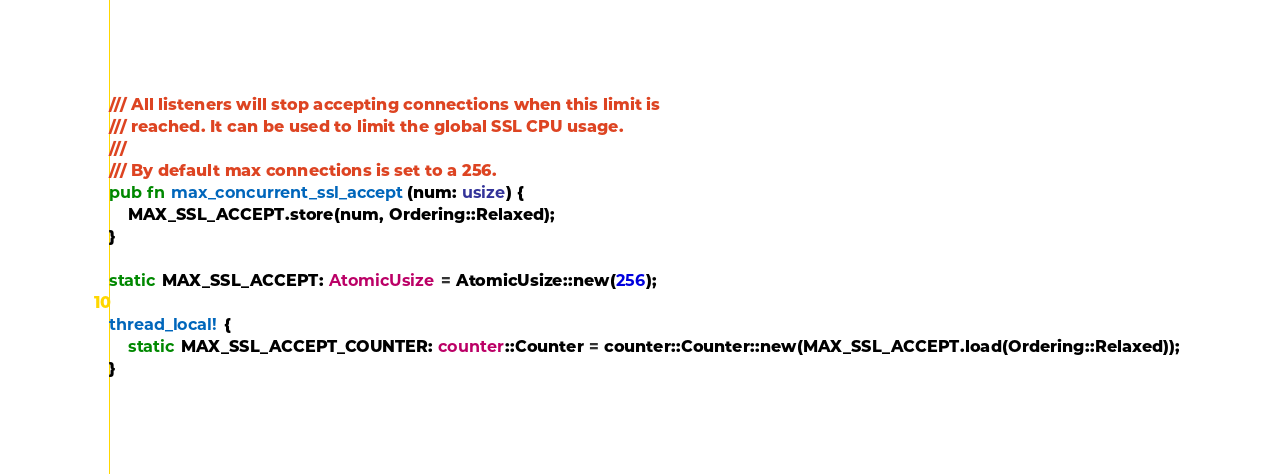<code> <loc_0><loc_0><loc_500><loc_500><_Rust_>/// All listeners will stop accepting connections when this limit is
/// reached. It can be used to limit the global SSL CPU usage.
///
/// By default max connections is set to a 256.
pub fn max_concurrent_ssl_accept(num: usize) {
    MAX_SSL_ACCEPT.store(num, Ordering::Relaxed);
}

static MAX_SSL_ACCEPT: AtomicUsize = AtomicUsize::new(256);

thread_local! {
    static MAX_SSL_ACCEPT_COUNTER: counter::Counter = counter::Counter::new(MAX_SSL_ACCEPT.load(Ordering::Relaxed));
}
</code> 